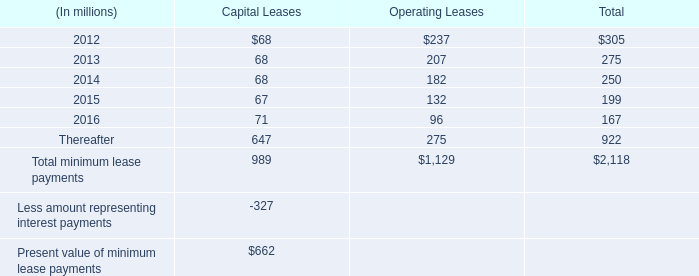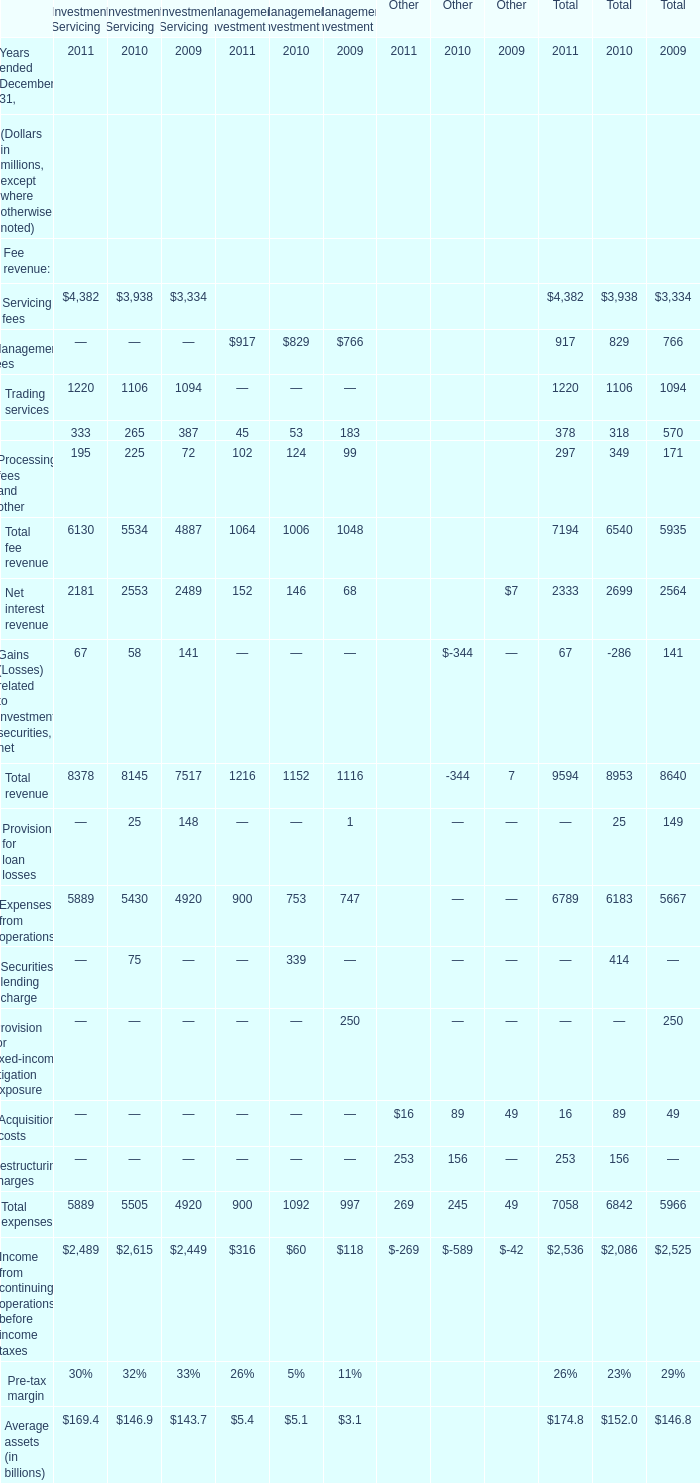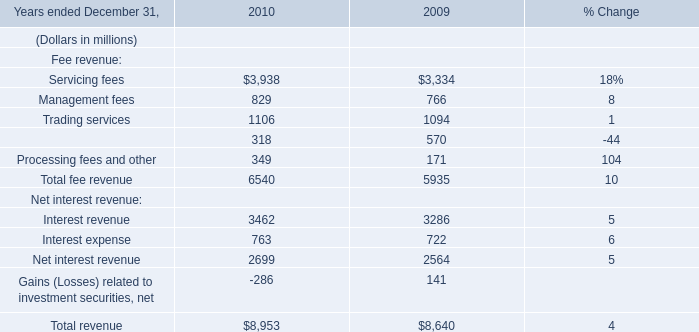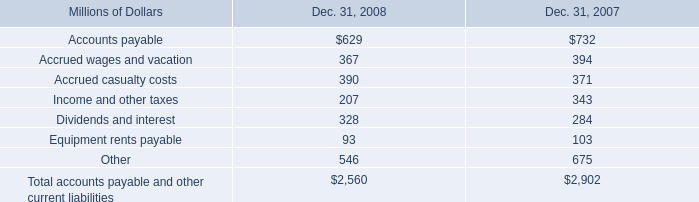Which year is Servicing fees for Investment Servicing greater than 4000 ? 
Answer: 2011. 